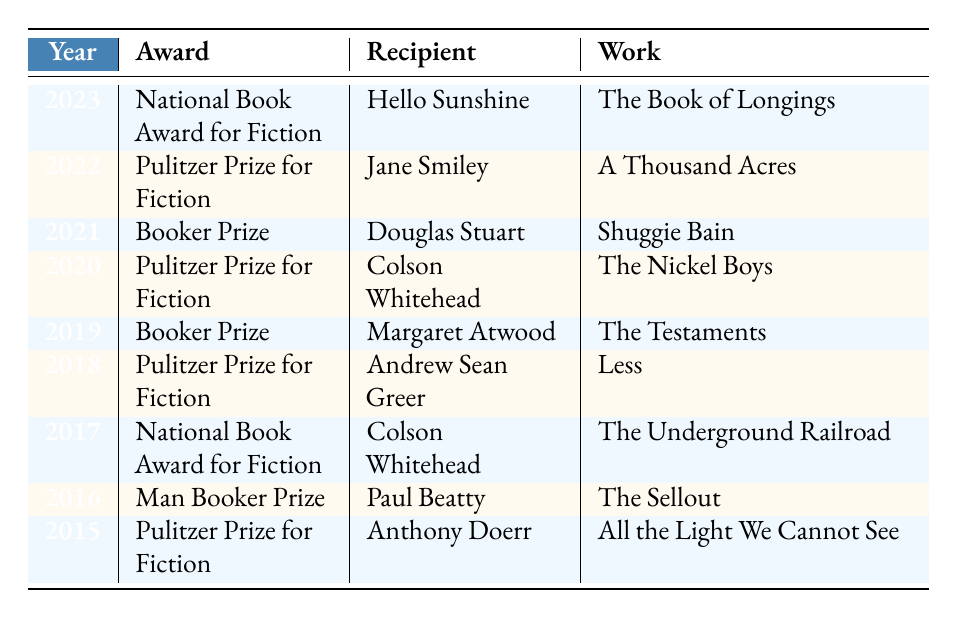What literary award did Colson Whitehead win in 2020? The table lists the awards by year, and in 2020, Colson Whitehead is listed as the recipient of the Pulitzer Prize for Fiction for the work "The Nickel Boys."
Answer: Pulitzer Prize for Fiction How many different authors won the Pulitzer Prize for Fiction from 2015 to 2022? By checking the table, we can see that the award was won by Anthony Doerr (2015), Andrew Sean Greer (2018), Colson Whitehead (2020), and Jane Smiley (2022). Therefore, there are four distinct authors who won this award during this period.
Answer: 4 Did any author win both the Pulitzer Prize for Fiction and the National Book Award for Fiction? The table shows that Colson Whitehead won the Pulitzer Prize for Fiction in 2020 and the National Book Award for Fiction in 2017. Thus, the answer is yes.
Answer: Yes What is the most recent literary award listed in the table, and who received it? The most recent year in the table is 2023, where the literary award is the National Book Award for Fiction, and it was awarded to Hello Sunshine for the work "The Book of Longings."
Answer: National Book Award for Fiction, Hello Sunshine Which year had two different names for the Booker Prize, and who won them? The term “Booker Prize” is used for both 2019 (won by Margaret Atwood) and 2021 (won by Douglas Stuart). So, the years are 2019 and 2021.
Answer: 2019 and 2021 What is the relationship between the years and the recipients for the Booker Prize? By evaluating the table, we notice that the Booker Prize was awarded in 2016 (Paul Beatty), 2019 (Margaret Atwood), and 2021 (Douglas Stuart). Hence, the years associated with this award and their respective recipients show a distribution over six years.
Answer: 2016 (Paul Beatty), 2019 (Margaret Atwood), 2021 (Douglas Stuart) In total, how many awards were given out from 2015 to 2023? The table lists a total of nine awards won from 2015 to 2023, as each row represents an individual award winner.
Answer: 9 Was there a year without any major literary award mentioned in the table? The table showcases awards for each year from 2015 to 2023; therefore, there were no gaps or missing years specified, indicating that each year saw a major literary award.
Answer: No 